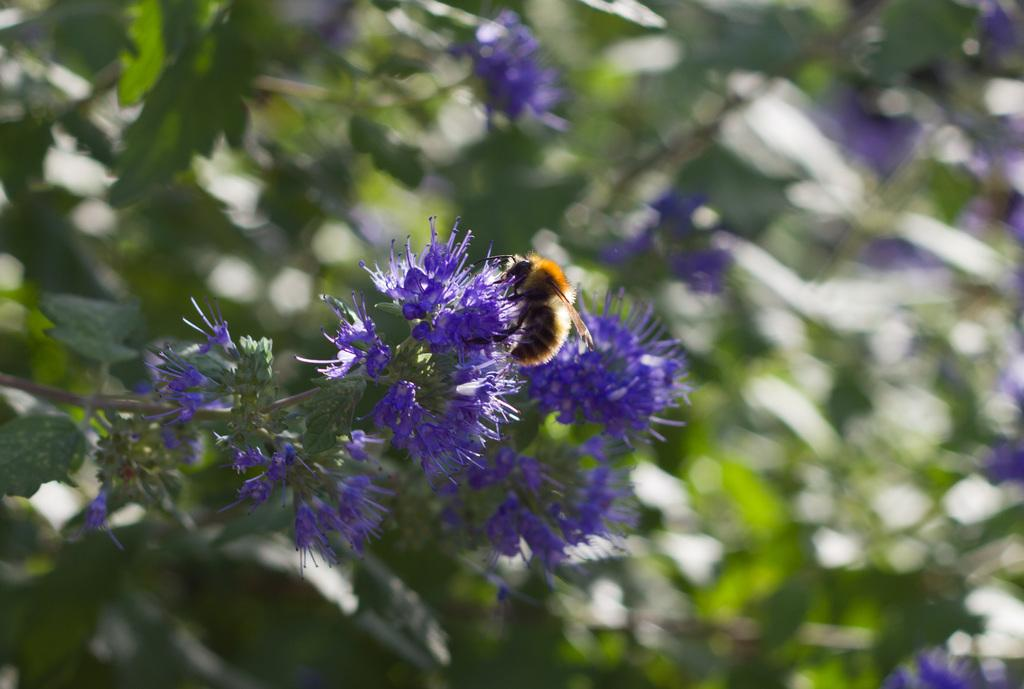What is present on the flower in the image? There is an insect on the flower in the image. What color are the flowers in the image? The flowers in the image are violet in color. What type of plant might the insect be found on in the image? The image likely depicts a tree with branches, leaves, and flowers. flowers. What type of fuel is the insect using to fly in the image? The image does not provide information about the insect's method of flight or the type of fuel it might be using. 